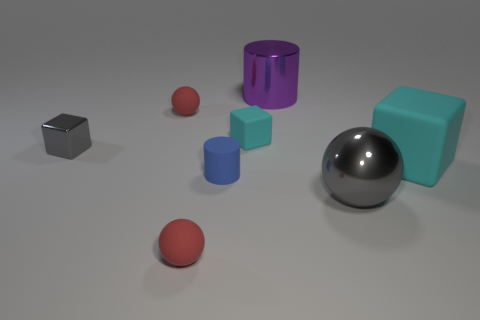Can you describe the lighting and shadows in the image? Certainly. The lighting in the image seems to be soft and diffused, coming from a direction that is not directly visible in the picture. This is indicated by the soft-edged shadows cast by the objects. The shadows are all aligned to the right of the objects, which suggests a light source to the left of the scene. The even lighting contributes to the calm and balanced feel of the composition. 